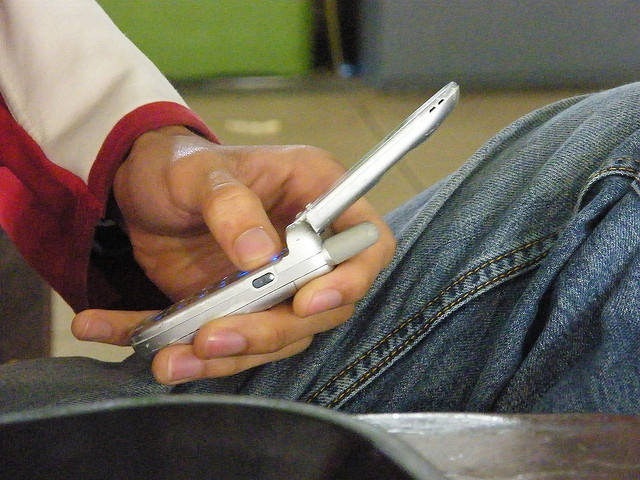Describe the objects in this image and their specific colors. I can see people in olive, black, gray, brown, and maroon tones and cell phone in olive, white, darkgray, gray, and lightgray tones in this image. 